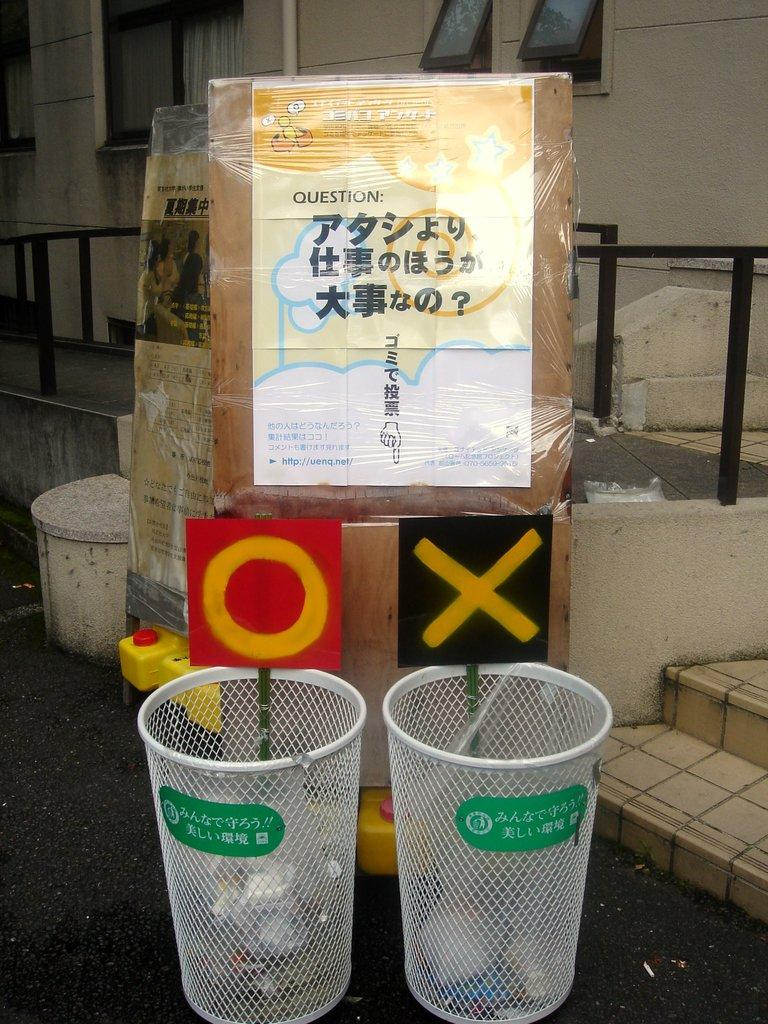<image>
Give a short and clear explanation of the subsequent image. Two trash cans have an "O" and an "X" above them. 